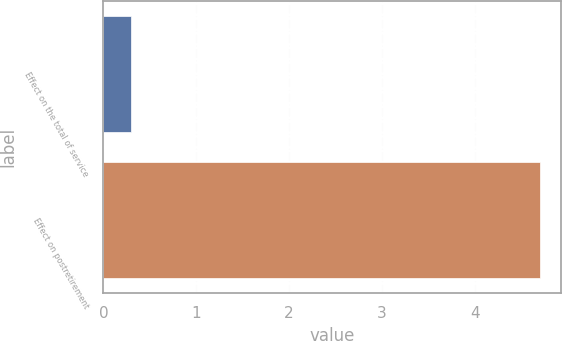Convert chart. <chart><loc_0><loc_0><loc_500><loc_500><bar_chart><fcel>Effect on the total of service<fcel>Effect on postretirement<nl><fcel>0.3<fcel>4.7<nl></chart> 